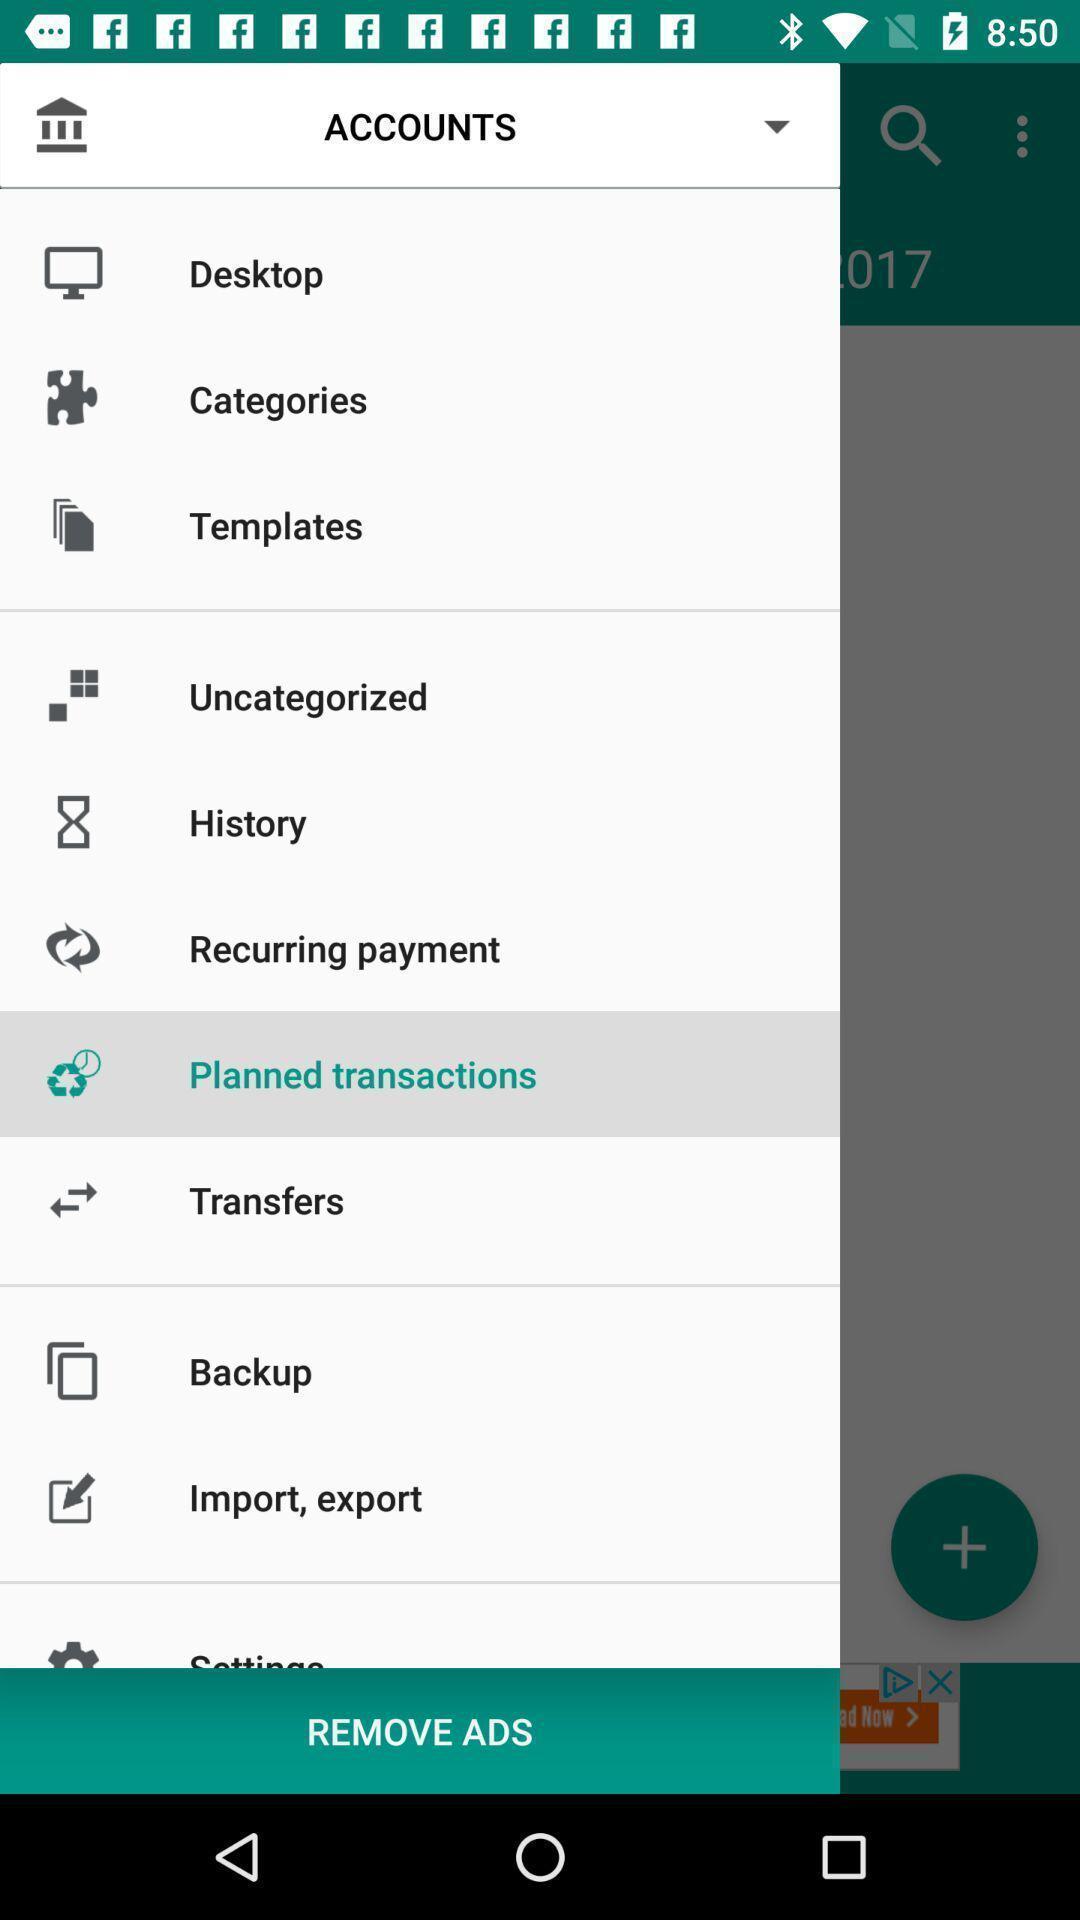Describe the key features of this screenshot. Page showing different options in the payment app. 